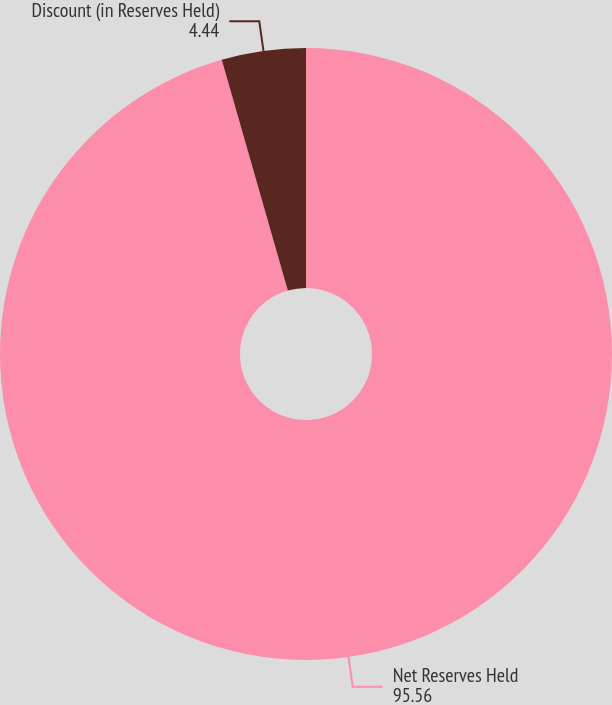<chart> <loc_0><loc_0><loc_500><loc_500><pie_chart><fcel>Net Reserves Held<fcel>Discount (in Reserves Held)<nl><fcel>95.56%<fcel>4.44%<nl></chart> 